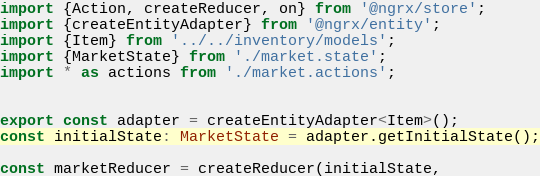<code> <loc_0><loc_0><loc_500><loc_500><_TypeScript_>import {Action, createReducer, on} from '@ngrx/store';
import {createEntityAdapter} from '@ngrx/entity';
import {Item} from '../../inventory/models';
import {MarketState} from './market.state';
import * as actions from './market.actions';


export const adapter = createEntityAdapter<Item>();
const initialState: MarketState = adapter.getInitialState();

const marketReducer = createReducer(initialState,</code> 